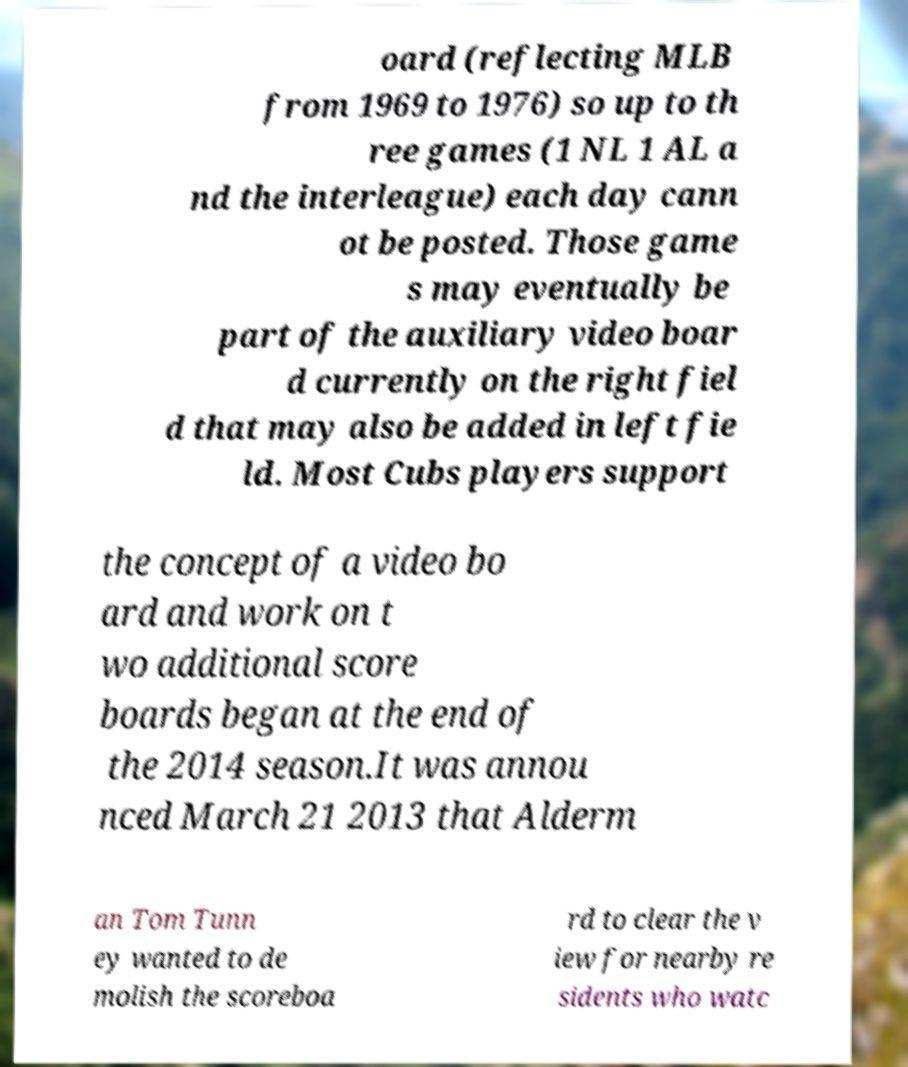Can you read and provide the text displayed in the image?This photo seems to have some interesting text. Can you extract and type it out for me? oard (reflecting MLB from 1969 to 1976) so up to th ree games (1 NL 1 AL a nd the interleague) each day cann ot be posted. Those game s may eventually be part of the auxiliary video boar d currently on the right fiel d that may also be added in left fie ld. Most Cubs players support the concept of a video bo ard and work on t wo additional score boards began at the end of the 2014 season.It was annou nced March 21 2013 that Alderm an Tom Tunn ey wanted to de molish the scoreboa rd to clear the v iew for nearby re sidents who watc 